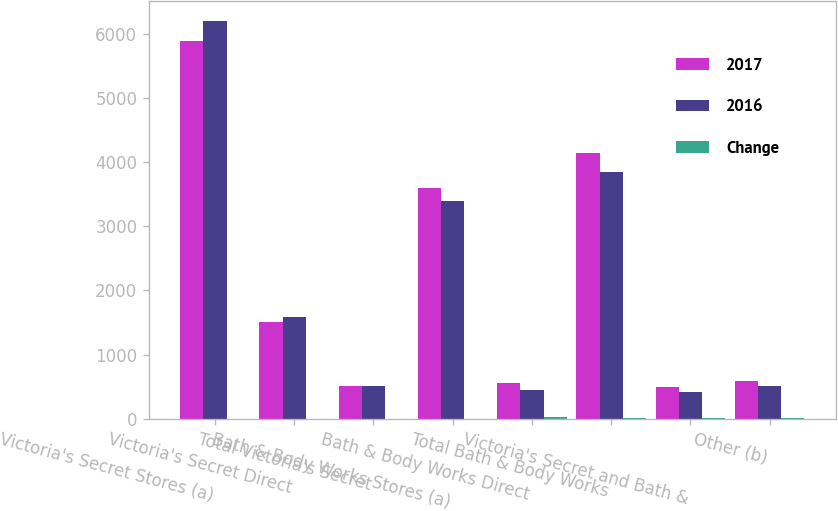Convert chart to OTSL. <chart><loc_0><loc_0><loc_500><loc_500><stacked_bar_chart><ecel><fcel>Victoria's Secret Stores (a)<fcel>Victoria's Secret Direct<fcel>Total Victoria's Secret<fcel>Bath & Body Works Stores (a)<fcel>Bath & Body Works Direct<fcel>Total Bath & Body Works<fcel>Victoria's Secret and Bath &<fcel>Other (b)<nl><fcel>2017<fcel>5879<fcel>1508<fcel>510<fcel>3589<fcel>559<fcel>4148<fcel>502<fcel>595<nl><fcel>2016<fcel>6199<fcel>1582<fcel>510<fcel>3400<fcel>452<fcel>3852<fcel>423<fcel>518<nl><fcel>Change<fcel>5<fcel>5<fcel>5<fcel>6<fcel>24<fcel>8<fcel>19<fcel>15<nl></chart> 